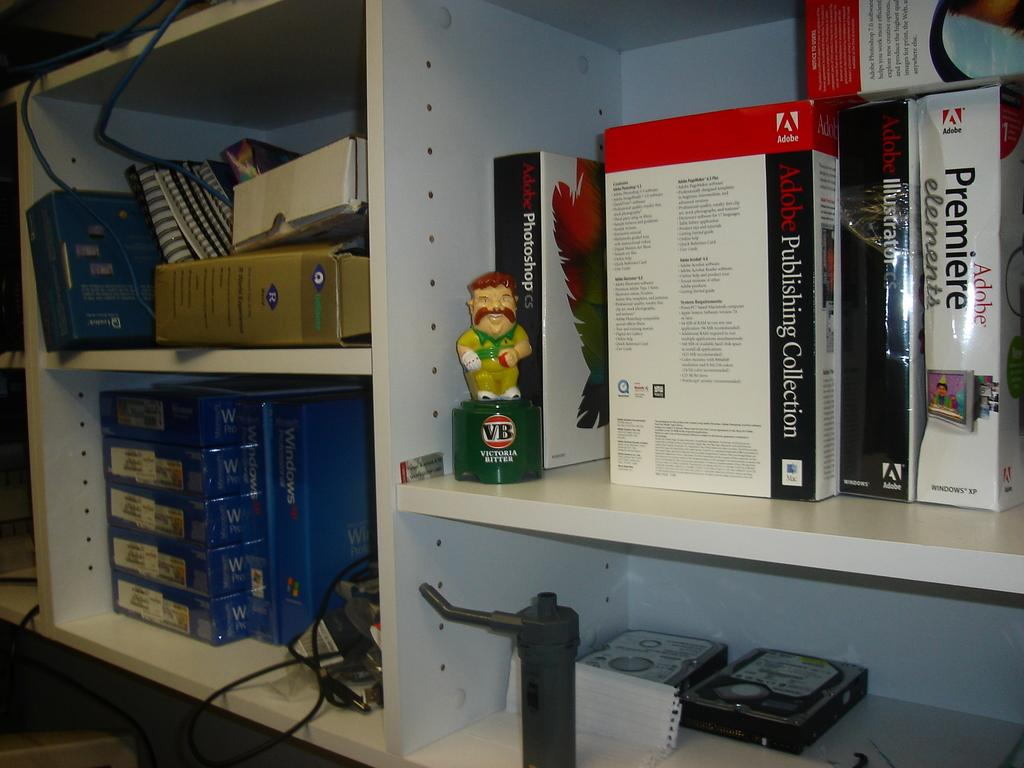<image>
Relay a brief, clear account of the picture shown. a shelf that has Adobe Premier on it 